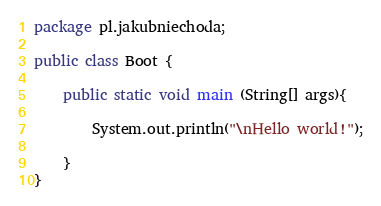Convert code to text. <code><loc_0><loc_0><loc_500><loc_500><_Java_>package pl.jakubniechoda;

public class Boot {

    public static void main (String[] args){

        System.out.println("\nHello world!");

    }
}
</code> 